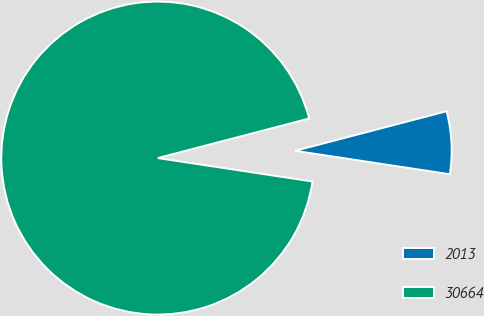Convert chart. <chart><loc_0><loc_0><loc_500><loc_500><pie_chart><fcel>2013<fcel>30664<nl><fcel>6.46%<fcel>93.54%<nl></chart> 